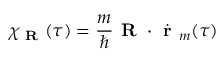Convert formula to latex. <formula><loc_0><loc_0><loc_500><loc_500>\chi _ { R } ( \tau ) = \frac { m } { } R \cdot \dot { r } _ { m } ( \tau )</formula> 